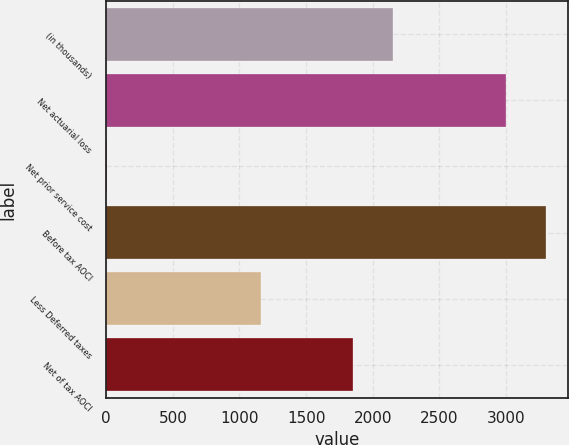Convert chart. <chart><loc_0><loc_0><loc_500><loc_500><bar_chart><fcel>(in thousands)<fcel>Net actuarial loss<fcel>Net prior service cost<fcel>Before tax AOCI<fcel>Less Deferred taxes<fcel>Net of tax AOCI<nl><fcel>2148.2<fcel>3002<fcel>8<fcel>3302.2<fcel>1162<fcel>1848<nl></chart> 